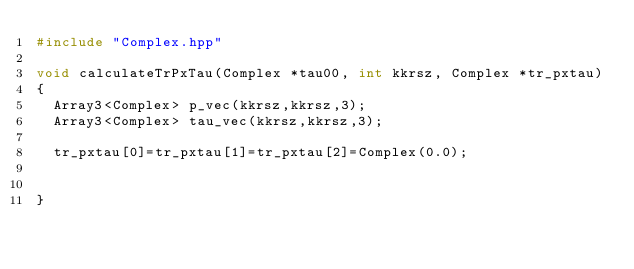Convert code to text. <code><loc_0><loc_0><loc_500><loc_500><_C++_>#include "Complex.hpp"

void calculateTrPxTau(Complex *tau00, int kkrsz, Complex *tr_pxtau)
{
  Array3<Complex> p_vec(kkrsz,kkrsz,3);
  Array3<Complex> tau_vec(kkrsz,kkrsz,3);

  tr_pxtau[0]=tr_pxtau[1]=tr_pxtau[2]=Complex(0.0);


}
</code> 